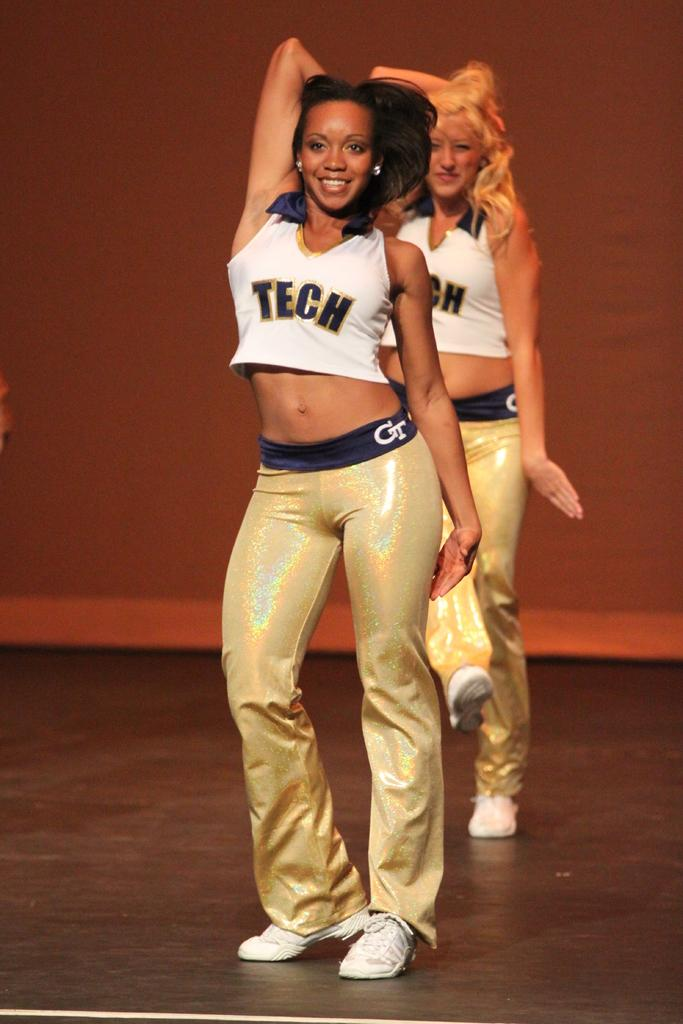Provide a one-sentence caption for the provided image. girls dancing together on stage shirt reads tech. 